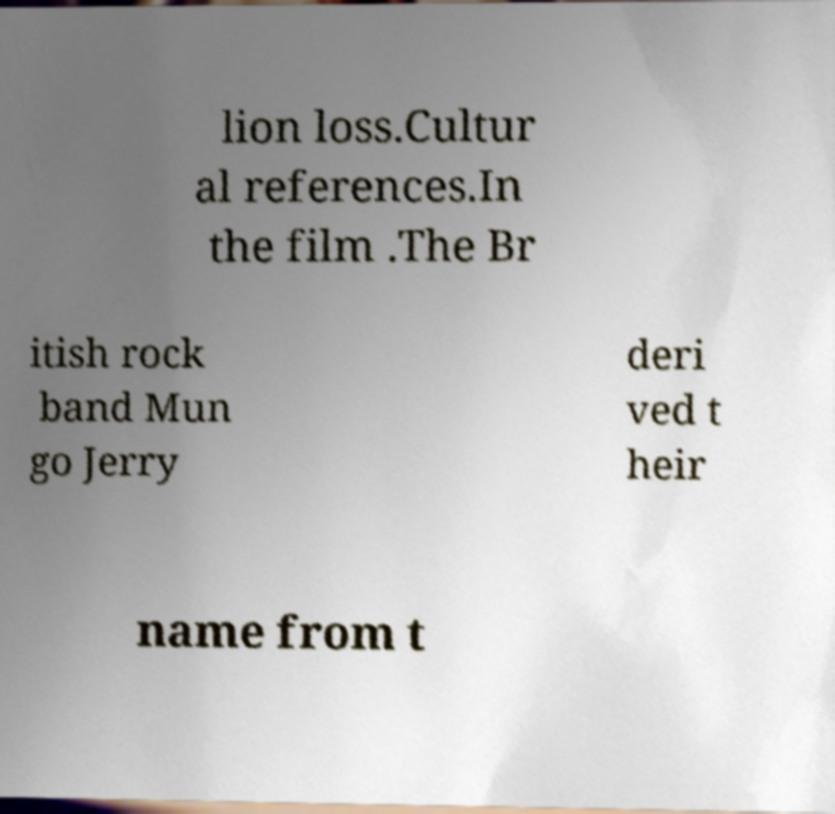There's text embedded in this image that I need extracted. Can you transcribe it verbatim? lion loss.Cultur al references.In the film .The Br itish rock band Mun go Jerry deri ved t heir name from t 